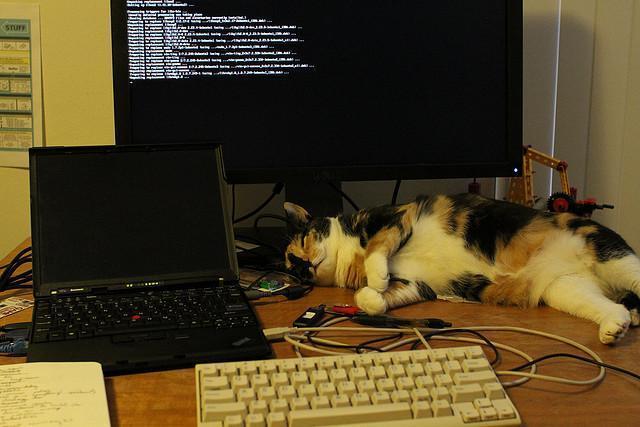How many keyboards are there?
Give a very brief answer. 2. 